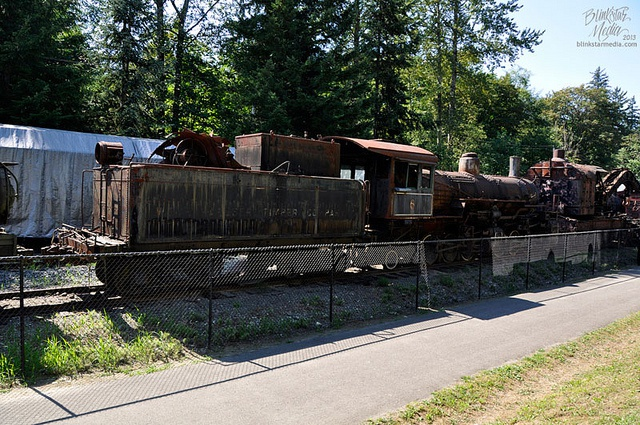Describe the objects in this image and their specific colors. I can see train in black, gray, darkgray, and maroon tones and train in black and gray tones in this image. 